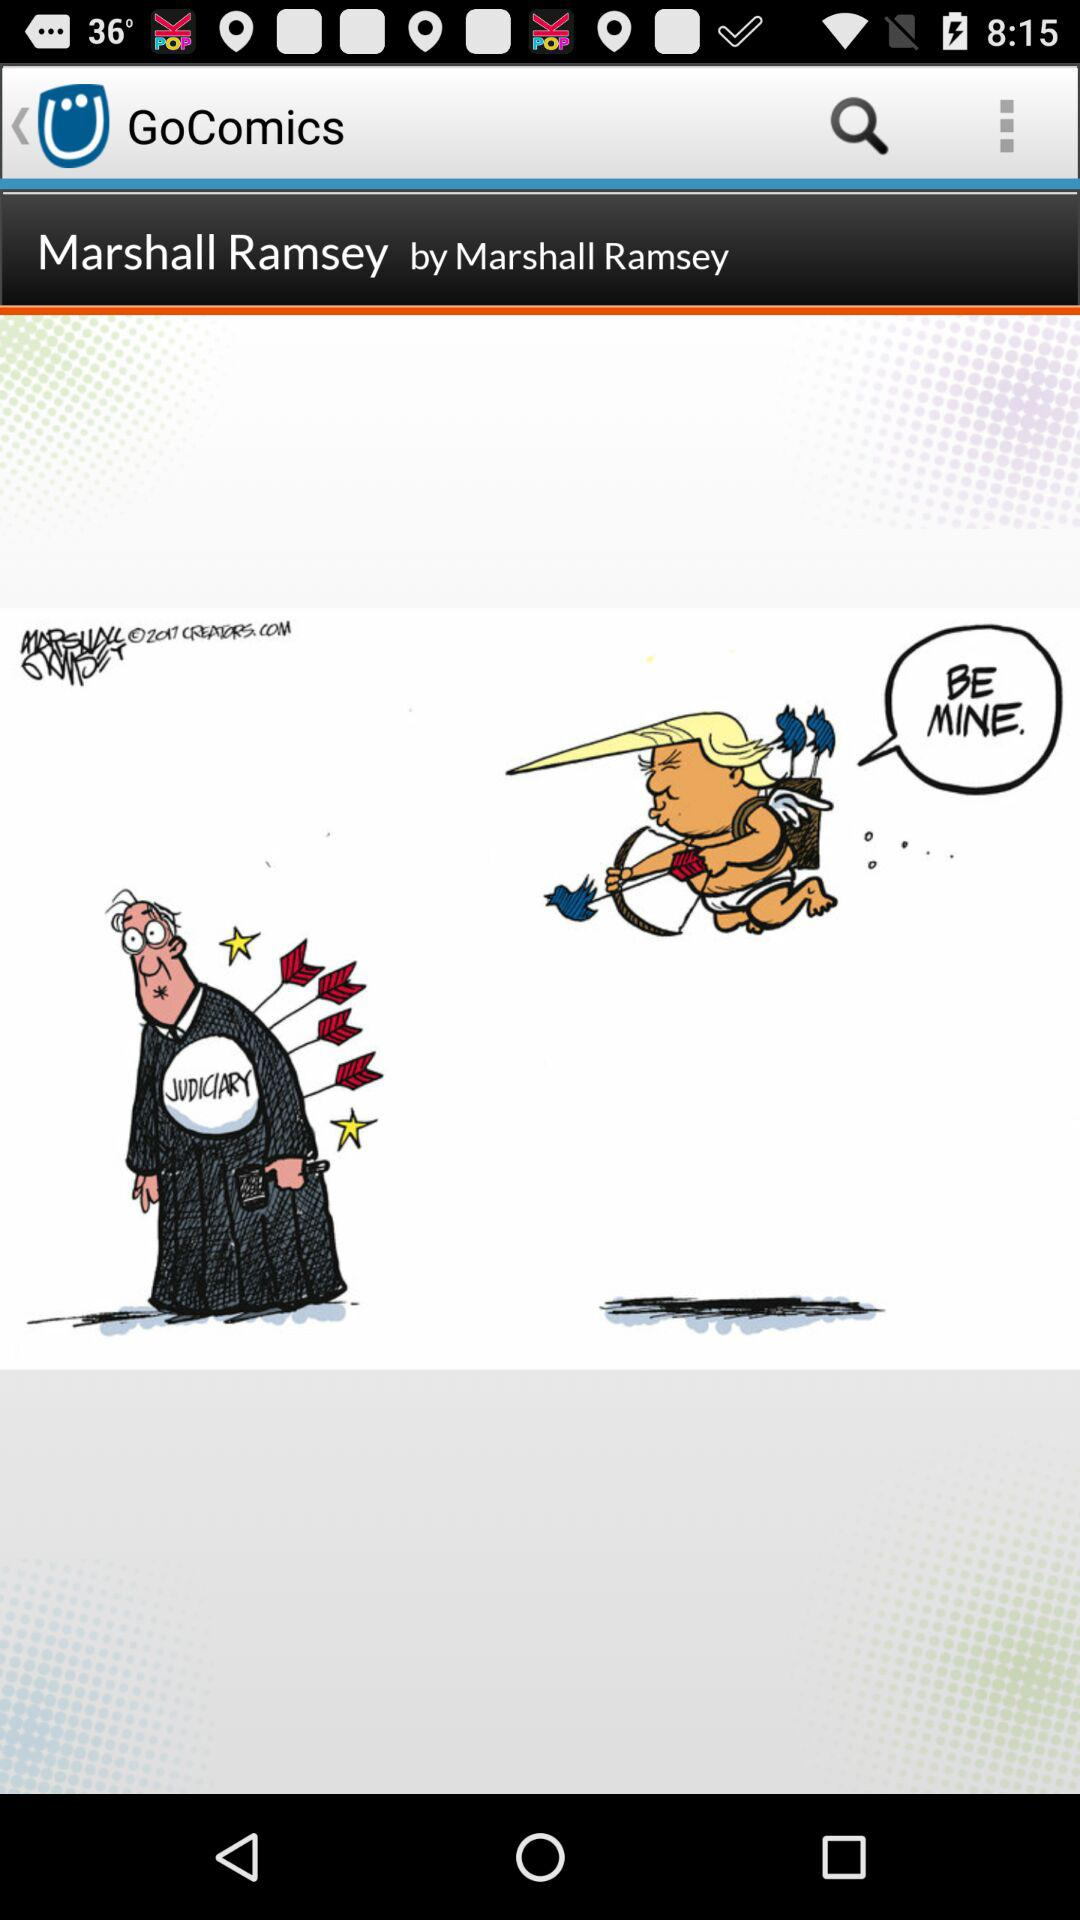Who is the writer of the comic? The writer is Marshall Ramsey. 